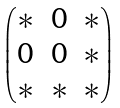Convert formula to latex. <formula><loc_0><loc_0><loc_500><loc_500>\begin{pmatrix} \ast & 0 & \ast \\ 0 & 0 & \ast \\ \ast & \ast & \ast \end{pmatrix}</formula> 